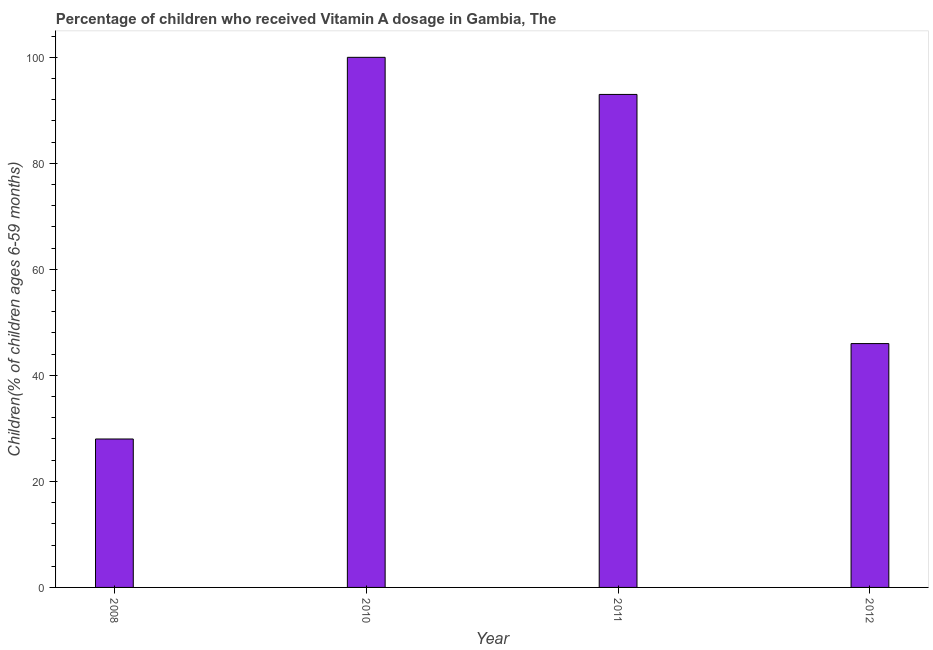Does the graph contain any zero values?
Your answer should be compact. No. What is the title of the graph?
Make the answer very short. Percentage of children who received Vitamin A dosage in Gambia, The. What is the label or title of the X-axis?
Keep it short and to the point. Year. What is the label or title of the Y-axis?
Offer a terse response. Children(% of children ages 6-59 months). What is the vitamin a supplementation coverage rate in 2008?
Ensure brevity in your answer.  28. What is the sum of the vitamin a supplementation coverage rate?
Your answer should be very brief. 267. What is the median vitamin a supplementation coverage rate?
Give a very brief answer. 69.5. In how many years, is the vitamin a supplementation coverage rate greater than 76 %?
Your answer should be very brief. 2. What is the ratio of the vitamin a supplementation coverage rate in 2011 to that in 2012?
Offer a terse response. 2.02. Is the vitamin a supplementation coverage rate in 2010 less than that in 2011?
Offer a very short reply. No. What is the difference between the highest and the lowest vitamin a supplementation coverage rate?
Ensure brevity in your answer.  72. What is the difference between two consecutive major ticks on the Y-axis?
Offer a very short reply. 20. Are the values on the major ticks of Y-axis written in scientific E-notation?
Your answer should be very brief. No. What is the Children(% of children ages 6-59 months) of 2011?
Offer a very short reply. 93. What is the difference between the Children(% of children ages 6-59 months) in 2008 and 2010?
Keep it short and to the point. -72. What is the difference between the Children(% of children ages 6-59 months) in 2008 and 2011?
Make the answer very short. -65. What is the difference between the Children(% of children ages 6-59 months) in 2010 and 2012?
Keep it short and to the point. 54. What is the difference between the Children(% of children ages 6-59 months) in 2011 and 2012?
Offer a very short reply. 47. What is the ratio of the Children(% of children ages 6-59 months) in 2008 to that in 2010?
Keep it short and to the point. 0.28. What is the ratio of the Children(% of children ages 6-59 months) in 2008 to that in 2011?
Provide a succinct answer. 0.3. What is the ratio of the Children(% of children ages 6-59 months) in 2008 to that in 2012?
Provide a succinct answer. 0.61. What is the ratio of the Children(% of children ages 6-59 months) in 2010 to that in 2011?
Keep it short and to the point. 1.07. What is the ratio of the Children(% of children ages 6-59 months) in 2010 to that in 2012?
Your answer should be compact. 2.17. What is the ratio of the Children(% of children ages 6-59 months) in 2011 to that in 2012?
Make the answer very short. 2.02. 